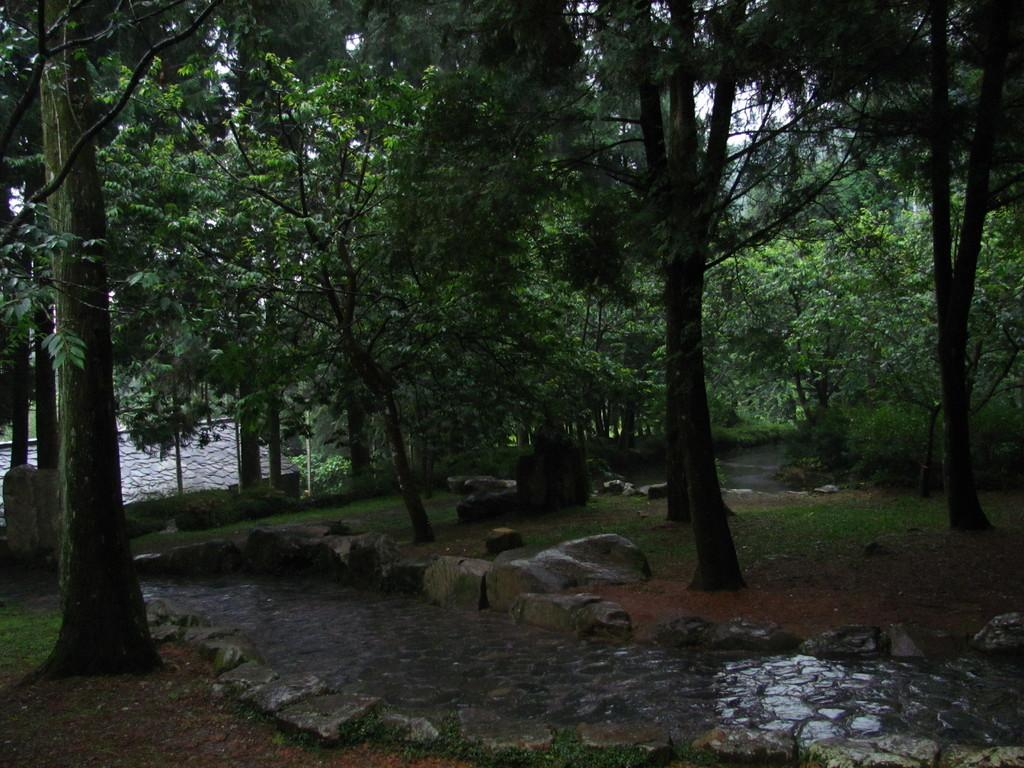What type of natural environment can be seen in the background of the image? There is a group of trees in the background of the image. What is located at the bottom of the image? There is a walkway at the bottom of the image. What type of terrain is present in the image? There are rocks and sand in the image. Can you see any copper in the image? There is no copper present in the image. Is there a ring visible in the image? There is no ring visible in the image. 